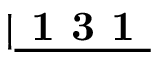Convert formula to latex. <formula><loc_0><loc_0><loc_500><loc_500>| \underline { 1 3 1 }</formula> 